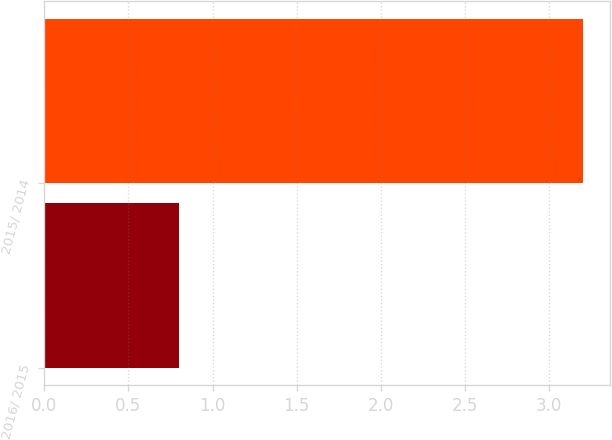Convert chart to OTSL. <chart><loc_0><loc_0><loc_500><loc_500><bar_chart><fcel>2016/ 2015<fcel>2015/ 2014<nl><fcel>0.8<fcel>3.2<nl></chart> 